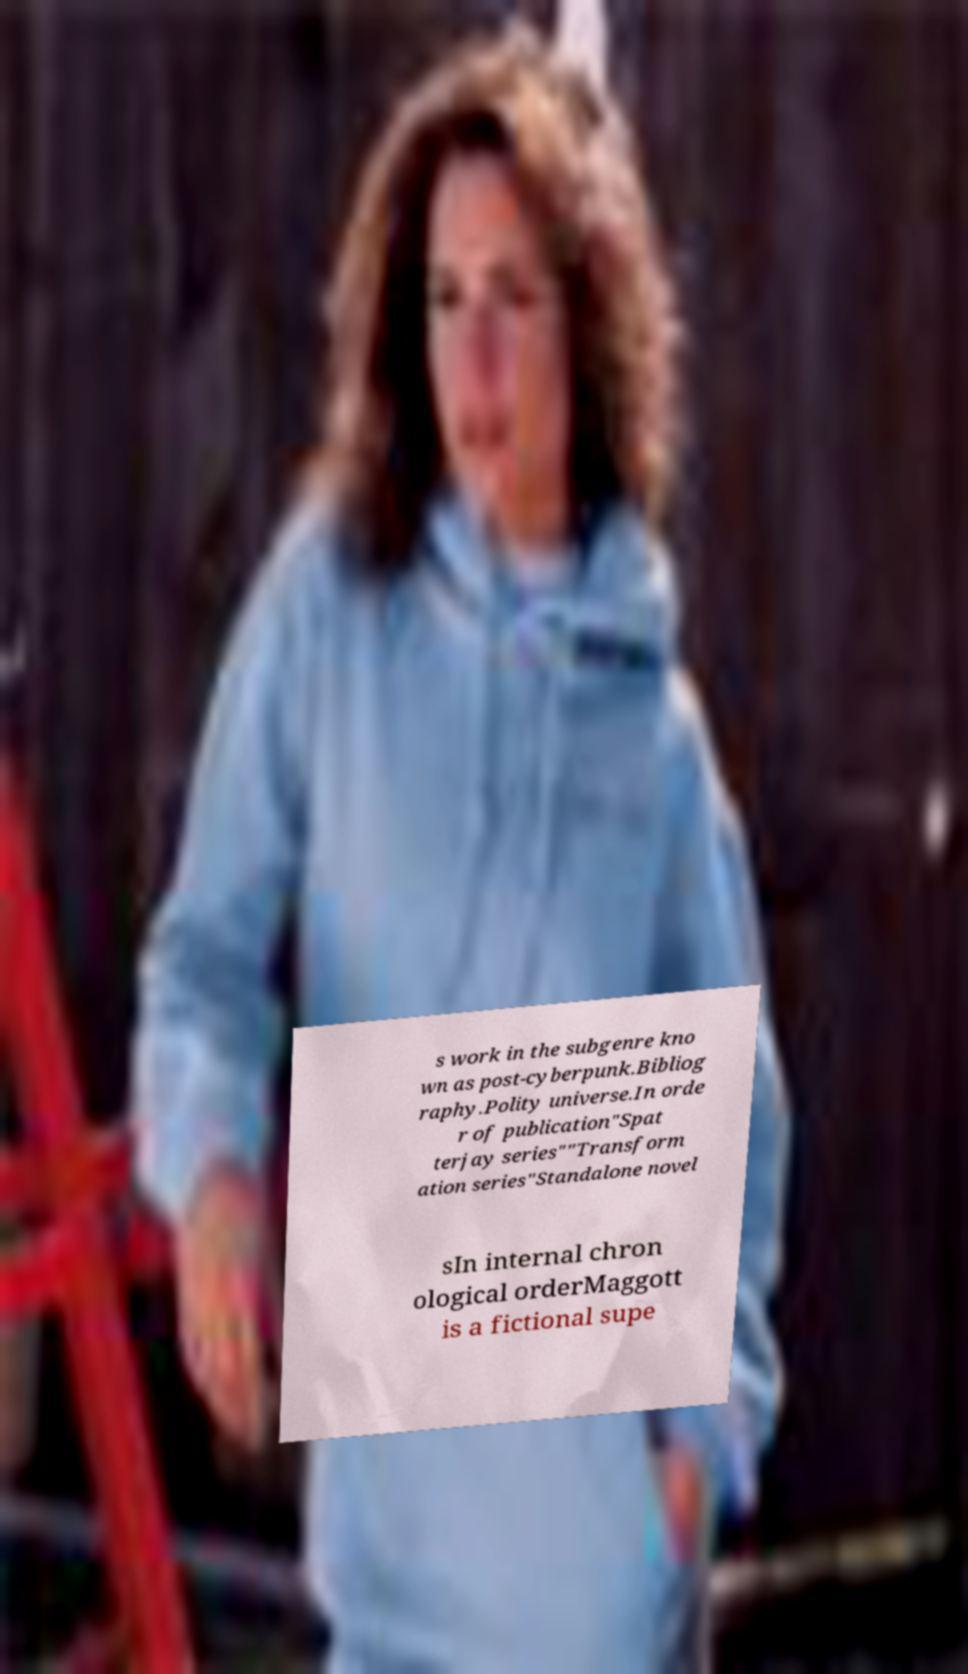What messages or text are displayed in this image? I need them in a readable, typed format. s work in the subgenre kno wn as post-cyberpunk.Bibliog raphy.Polity universe.In orde r of publication"Spat terjay series""Transform ation series"Standalone novel sIn internal chron ological orderMaggott is a fictional supe 